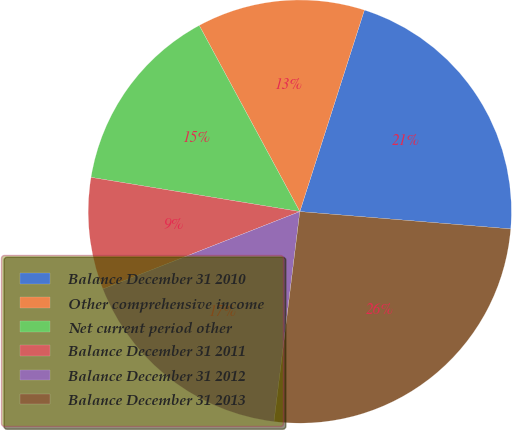<chart> <loc_0><loc_0><loc_500><loc_500><pie_chart><fcel>Balance December 31 2010<fcel>Other comprehensive income<fcel>Net current period other<fcel>Balance December 31 2011<fcel>Balance December 31 2012<fcel>Balance December 31 2013<nl><fcel>21.37%<fcel>12.82%<fcel>14.53%<fcel>8.55%<fcel>17.09%<fcel>25.64%<nl></chart> 